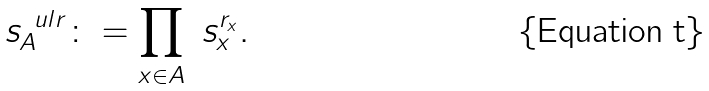Convert formula to latex. <formula><loc_0><loc_0><loc_500><loc_500>\ s ^ { \ u l r } _ { A } \colon = \prod _ { x \in A } \ s ^ { r _ { x } } _ { x } .</formula> 